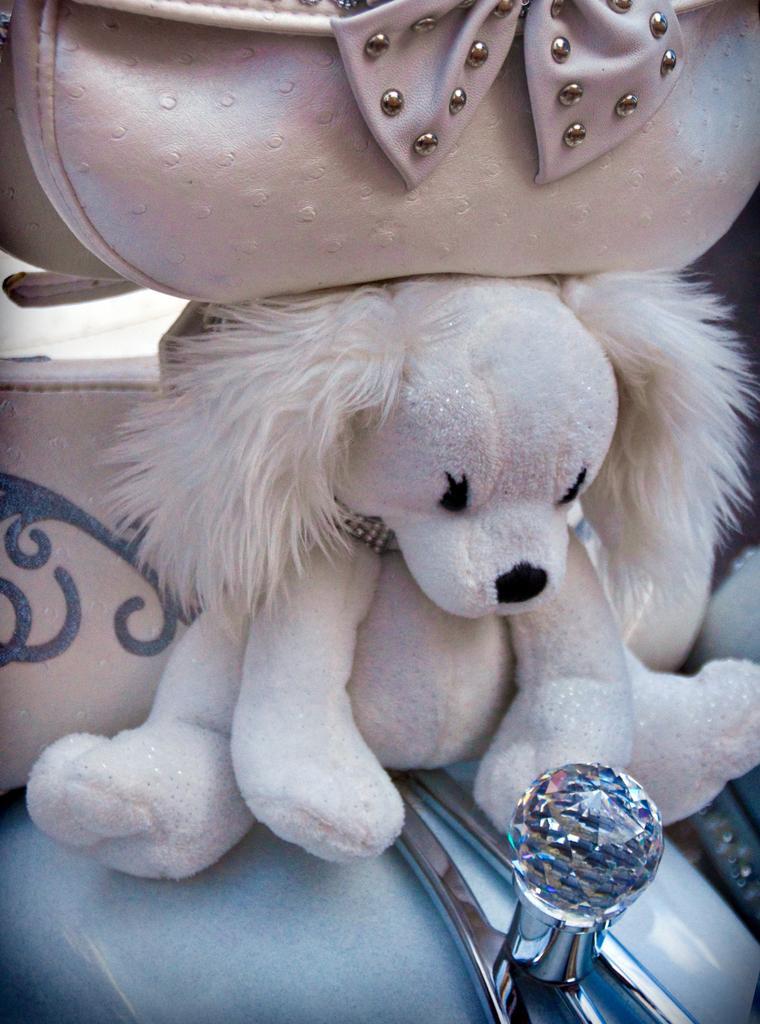Describe this image in one or two sentences. This image consists of a doll above which there is a handbag. It looks like it is kept on a vehicle. 